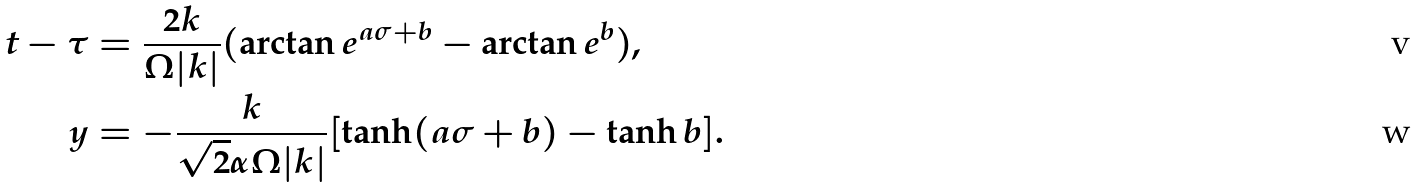<formula> <loc_0><loc_0><loc_500><loc_500>t - \tau & = \frac { 2 k } { \Omega | k | } ( \arctan e ^ { a \sigma + b } - \arctan e ^ { b } ) , \\ y & = - \frac { k } { \sqrt { 2 } \alpha \Omega | k | } [ \tanh ( a \sigma + b ) - \tanh b ] .</formula> 